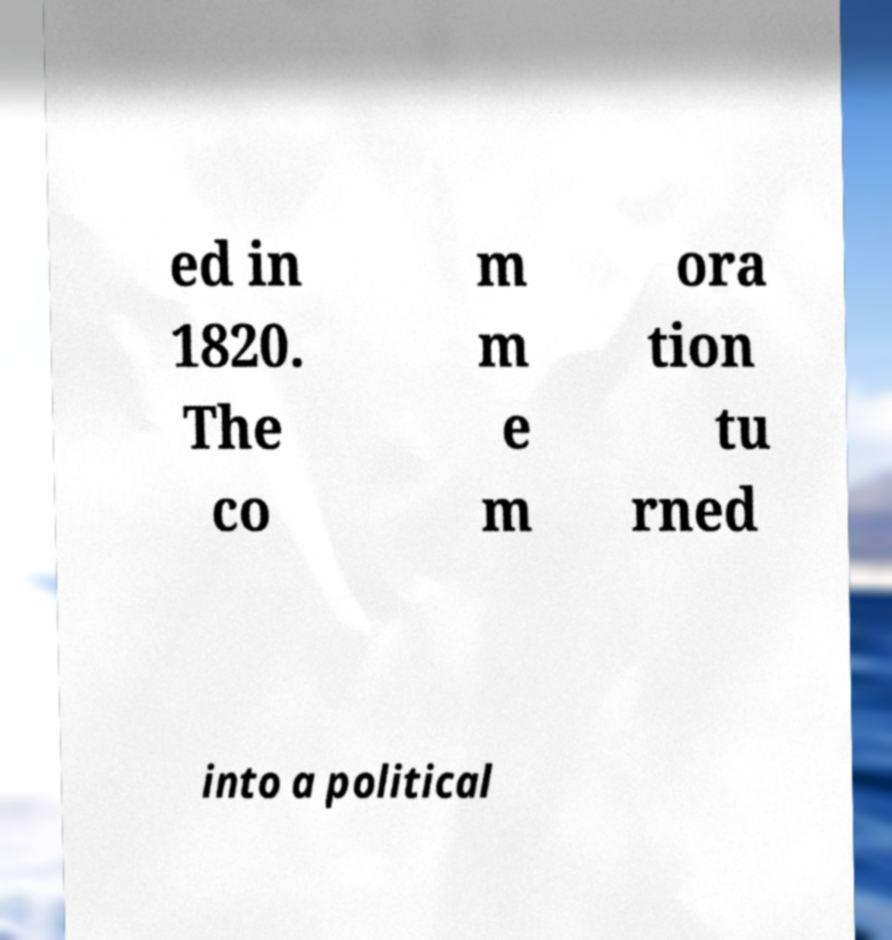Please read and relay the text visible in this image. What does it say? ed in 1820. The co m m e m ora tion tu rned into a political 